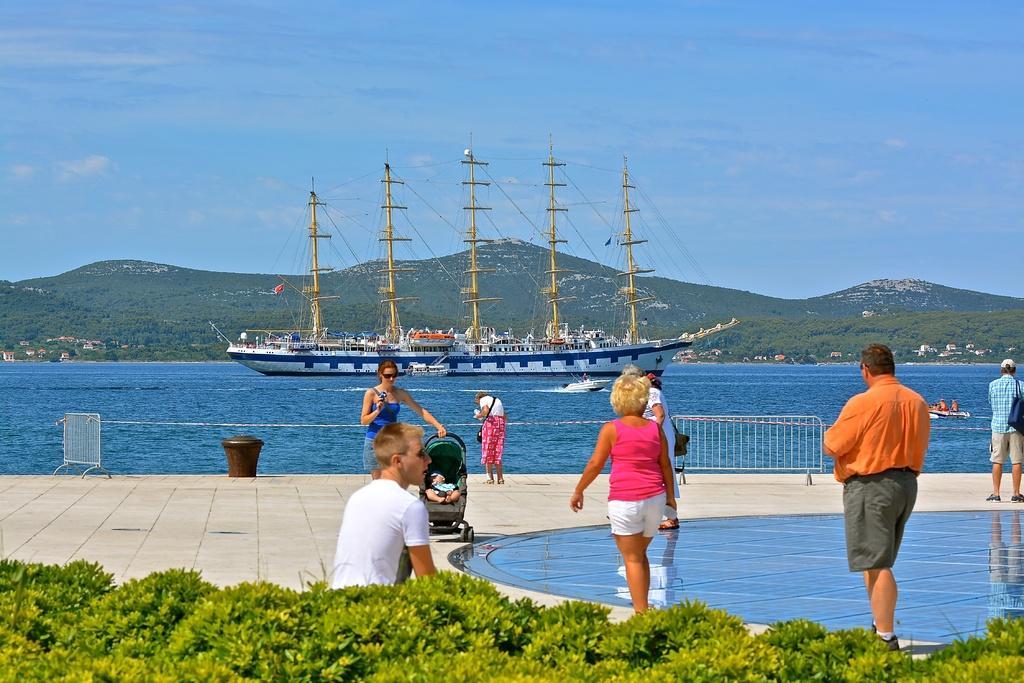How would you summarize this image in a sentence or two? In the foreground I can see plants, grass, vehicle, group of people on the floor. In the background I can see fence, ships in the water, houses, buildings, trees, mountains, boat and the sky. This image is taken may be during a day. 